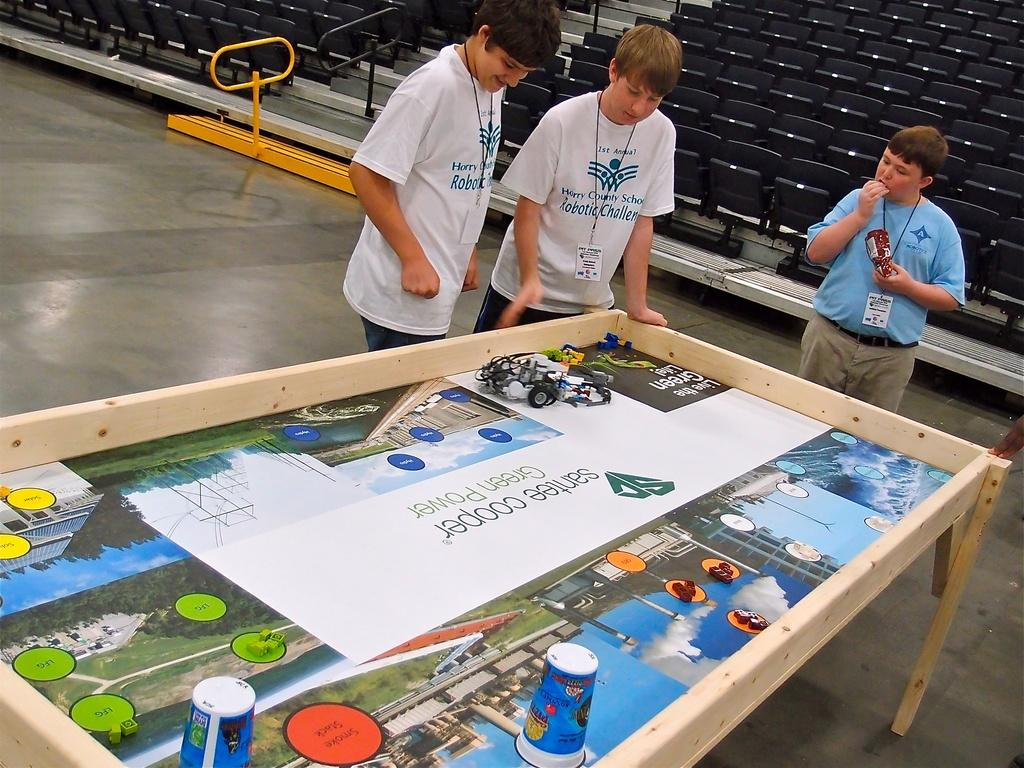How many people are in the image? There are three persons in the image. What is located behind the persons in the image? There are chairs at the back in the image. What is in front of the persons in the image? There is a table in front of the persons in the image. What type of objects can be seen in the image besides the persons, chairs, and table? There are toys in the image. What color is the sheet draped over the crook in the image? There is no sheet or crook present in the image. 